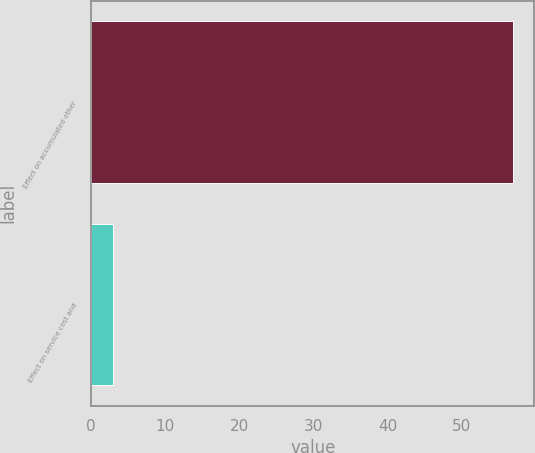Convert chart to OTSL. <chart><loc_0><loc_0><loc_500><loc_500><bar_chart><fcel>Effect on accumulated other<fcel>Effect on service cost and<nl><fcel>57<fcel>3<nl></chart> 